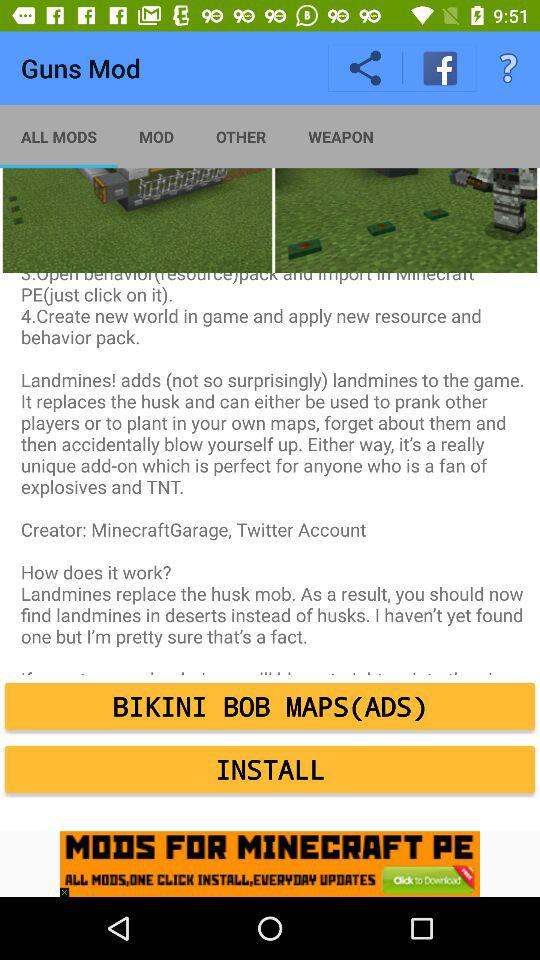Which tab is selected? The selected tab is "ALL MODS". 